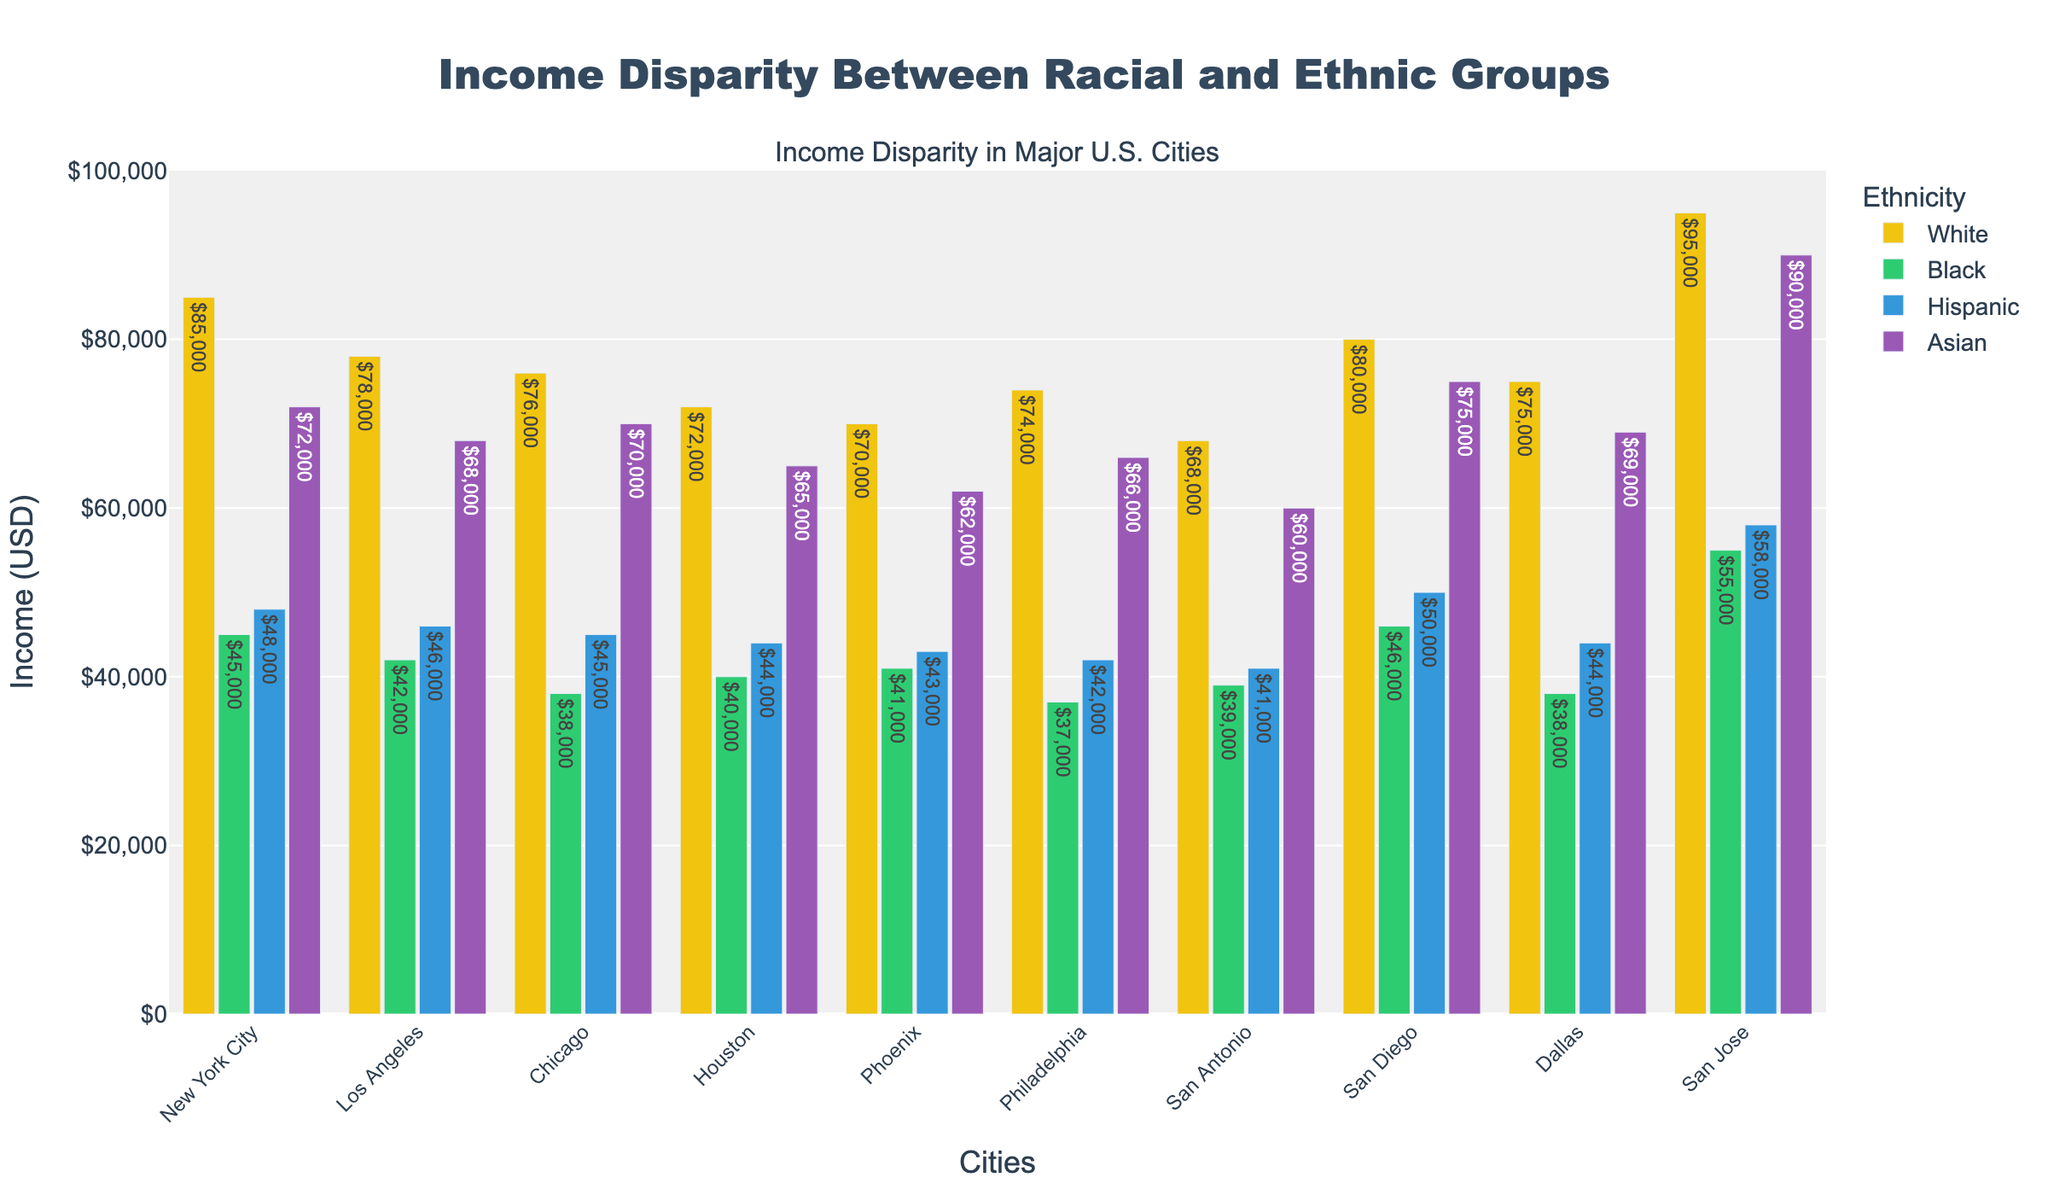What is the average income disparity between White and Black individuals across all cities? To find the average income disparity, subtract the income of Black individuals from the income of White individuals for each city and then find the average: 
New York City: 85000 - 45000 = 40000
Los Angeles: 78000 - 42000 = 36000
Chicago: 76000 - 38000 = 38000
Houston: 72000 - 40000 = 32000
Phoenix: 70000 - 41000 = 29000
Philadelphia: 74000 - 37000 = 37000
San Antonio: 68000 - 39000 = 29000
San Diego: 80000 - 46000 = 34000
Dallas: 75000 - 38000 = 37000
San Jose: 95000 - 55000 = 40000
Sum of disparities = 40000 + 36000 + 38000 + 32000 + 29000 + 37000 + 29000 + 34000 + 37000 + 40000 = 352000
Average disparity = 352000 / 10 = 35200
Answer: 35200 Which city has the smallest income gap between White and Hispanic individuals? Calculate the income gap (absolute difference) between White and Hispanic individuals for each city and find the smallest:
New York City: 85000 - 48000 = 37000
Los Angeles: 78000 - 46000 = 32000
Chicago: 76000 - 45000 = 31000
Houston: 72000 - 44000 = 28000
Phoenix: 70000 - 43000 = 27000
Philadelphia: 74000 - 42000 = 32000
San Antonio: 68000 - 41000 = 27000
San Diego: 80000 - 50000 = 30000
Dallas: 75000 - 44000 = 31000
San Jose: 95000 - 58000 = 37000
Smallest income gaps: Houston and San Antonio, both with $27000
Answer: Houston and San Antonio Which ethnicity has the highest average income across all cities? To find the highest average income, calculate the average for each ethnicity:
White: (85000 + 78000 + 76000 + 72000 + 70000 + 74000 + 68000 + 80000 + 75000 + 95000) / 10 = 772000 / 10 = 77200
Black: (45000 + 42000 + 38000 + 40000 + 41000 + 37000 + 39000 + 46000 + 38000 + 55000) / 10 = 421000 / 10 = 42100
Hispanic: (48000 + 46000 + 45000 + 44000 + 43000 + 42000 + 41000 + 50000 + 44000 + 58000) / 10 = 451000 / 10 = 45100
Asian: (72000 + 68000 + 70000 + 65000 + 62000 + 66000 + 60000 + 75000 + 69000 + 90000) / 10 = 707000 / 10 = 70700
White has the highest average income
Answer: White In which city do Hispanic individuals have the highest income? Compare the income of Hispanic individuals in all cities:
New York City: 48000
Los Angeles: 46000
Chicago: 45000
Houston: 44000
Phoenix: 43000
Philadelphia: 42000
San Antonio: 41000
San Diego: 50000
Dallas: 44000
San Jose: 58000
San Jose has the highest income for Hispanic individuals
Answer: San Jose What is the total income of Asian individuals in the four largest cities by population (NYC, LA, Chicago, Houston)? Sum the income of Asian individuals in the specified cities:
New York City: 72000
Los Angeles: 68000
Chicago: 70000
Houston: 65000
Total = 72000 + 68000 + 70000 + 65000 = 275000
Answer: 275000 Which ethnicity experiences the largest income disparity from the White ethnicity in San Jose? Calculate the disparity between White and each other ethnicity in San Jose:
Black: 95000 - 55000 = 40000
Hispanic: 95000 - 58000 = 37000
Asian: 95000 - 90000 = 5000
The largest disparity is with Black
Answer: Black Which city shows the smallest income disparity between Black and Hispanic individuals? Calculate the disparity between Black and Hispanic individuals for each city:
New York City: 45000 - 48000 = -3000
Los Angeles: 42000 - 46000 = -4000
Chicago: 38000 - 45000 = -7000
Houston: 40000 - 44000 = -4000
Phoenix: 41000 - 43000 = -2000
Philadelphia: 37000 - 42000 = -5000
San Antonio: 39000 - 41000 = -2000
San Diego: 46000 - 50000 = -4000
Dallas: 38000 - 44000 = -6000
San Jose: 55000 - 58000 = -3000
The smallest disparity is in Phoenix and San Antonio, both with -2000 (absolute value 2000)
Answer: Phoenix and San Antonio 